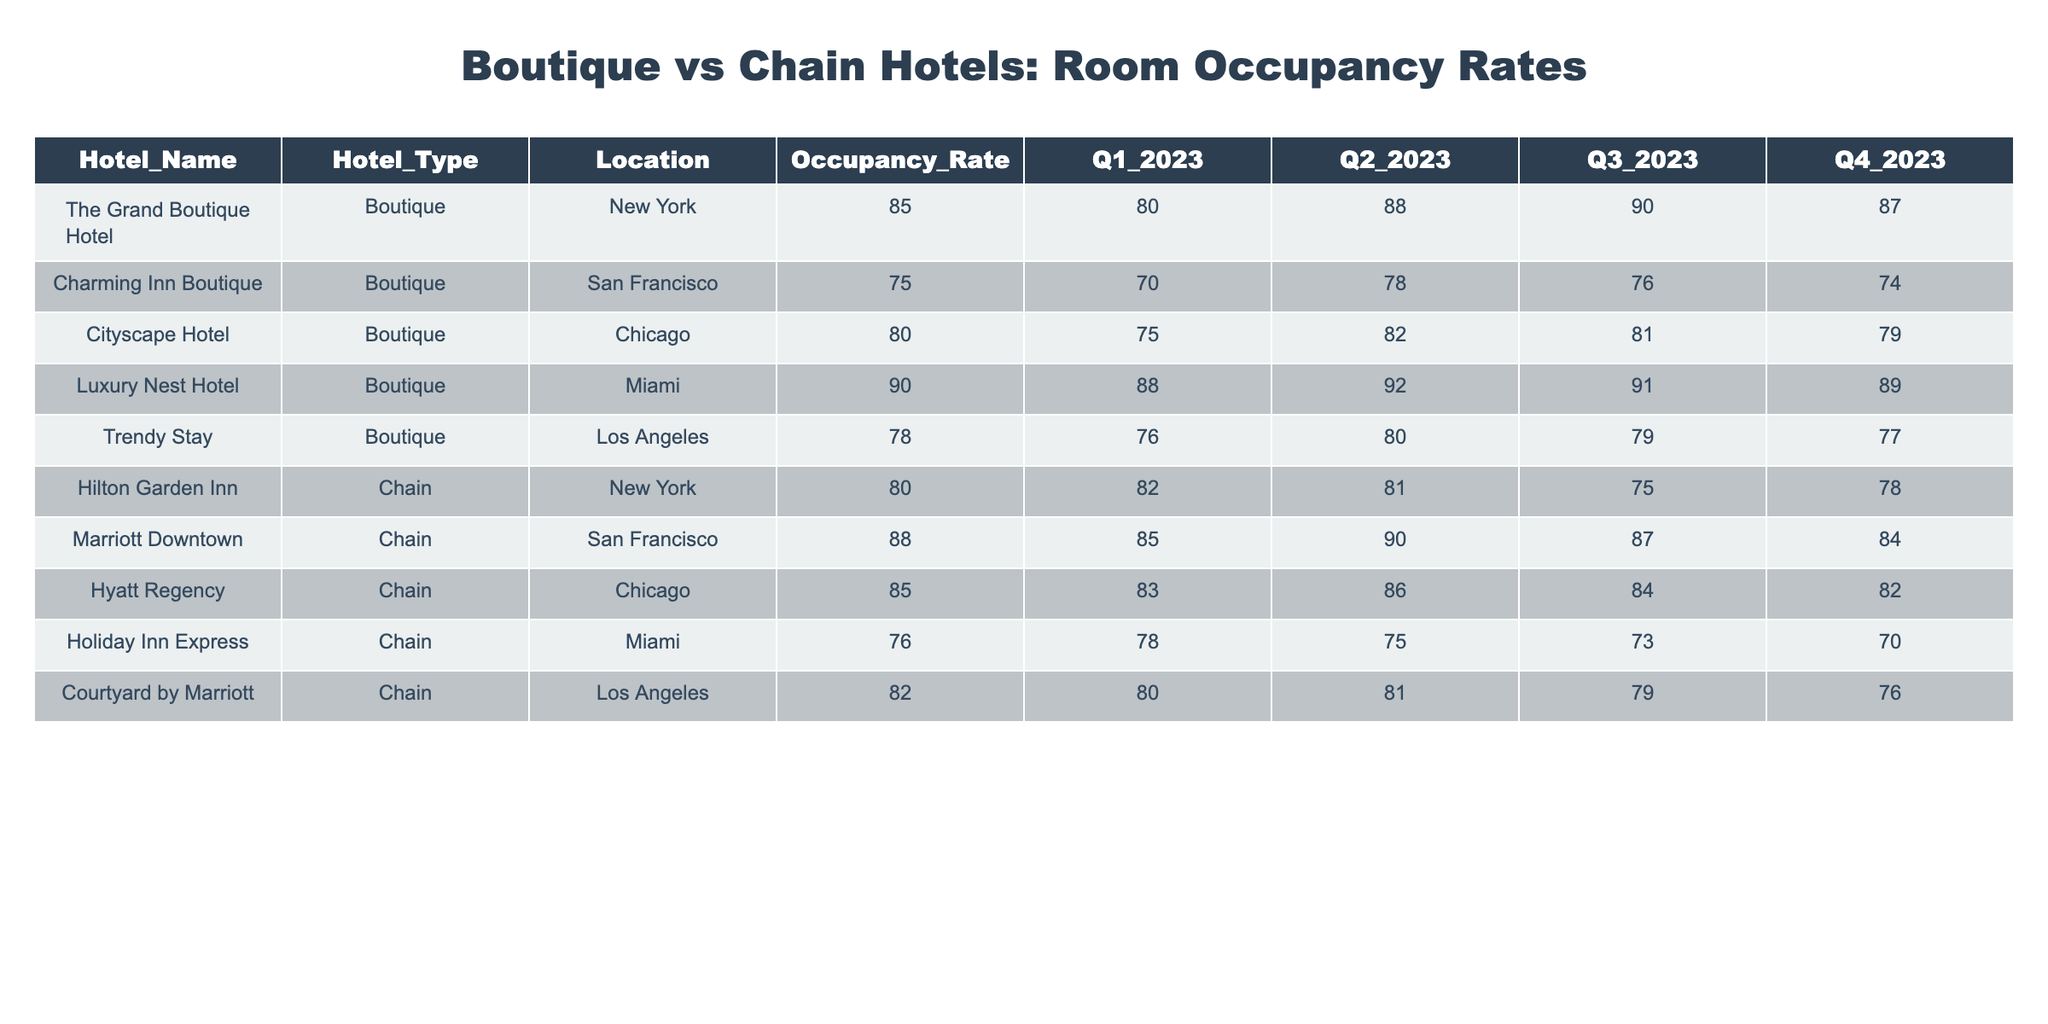What is the occupancy rate of Luxury Nest Hotel? The table shows that Luxury Nest Hotel has an occupancy rate of 90.
Answer: 90 Which hotel located in San Francisco has the higher occupancy rate, Charming Inn Boutique or Marriott Downtown? According to the table, Charming Inn Boutique has a rate of 75, while Marriott Downtown has a rate of 88. Marriott Downtown has a higher occupancy rate.
Answer: Marriott Downtown What is the average occupancy rate for all boutique hotels? The occupancy rates for boutique hotels are 85, 75, 80, 90, and 78. Adding these gives 85 + 75 + 80 + 90 + 78 = 408. Dividing by 5 gives an average of 408/5 = 81.6.
Answer: 81.6 Which hotel has the lowest occupancy rate overall? The lowest occupancy rate is seen for Holiday Inn Express with a rate of 76.
Answer: Holiday Inn Express Is the occupancy rate of Hilton Garden Inn higher than that of Cityscape Hotel? Hilton Garden Inn's occupancy rate is 80, while Cityscape Hotel's is 80 as well. Therefore, they are equal; Hilton Garden Inn is not higher.
Answer: No What is the difference in occupancy rates between the best-performing boutique hotel and the best-performing chain hotel? The best-performing boutique hotel is Luxury Nest Hotel with 90, and the best-performing chain hotel is Marriott Downtown with 88. The difference is 90 - 88 = 2.
Answer: 2 Which type of hotel has a better average occupancy rate based on the data provided? For boutique hotels, the rates are 85, 75, 80, 90, and 78, averaging 81.6. For chain hotels, the rates are 80, 88, 85, 76, and 82, averaging 82.2. Chain hotels have a better average occupancy rate since 82.2 is higher than 81.6.
Answer: Chain hotels What percentage of the quarter with the highest occupancy rate does the Luxury Nest Hotel achieve compared to its lowest quarter? Luxury Nest Hotel has rates of 92 and 89 in the respective quarters. The percentage increase from the lowest rate to the highest is (92 - 89) / 89 * 100 = 3.37%.
Answer: 3.37% How many boutique hotels have a higher occupancy rate than the lowest chain hotel? The lowest chain hotel, Holiday Inn Express, has an occupancy rate of 76. The boutique hotels that exceed this rate are The Grand Boutique Hotel, Cityscape Hotel, Luxury Nest Hotel, and Trendy Stay, totaling four.
Answer: 4 